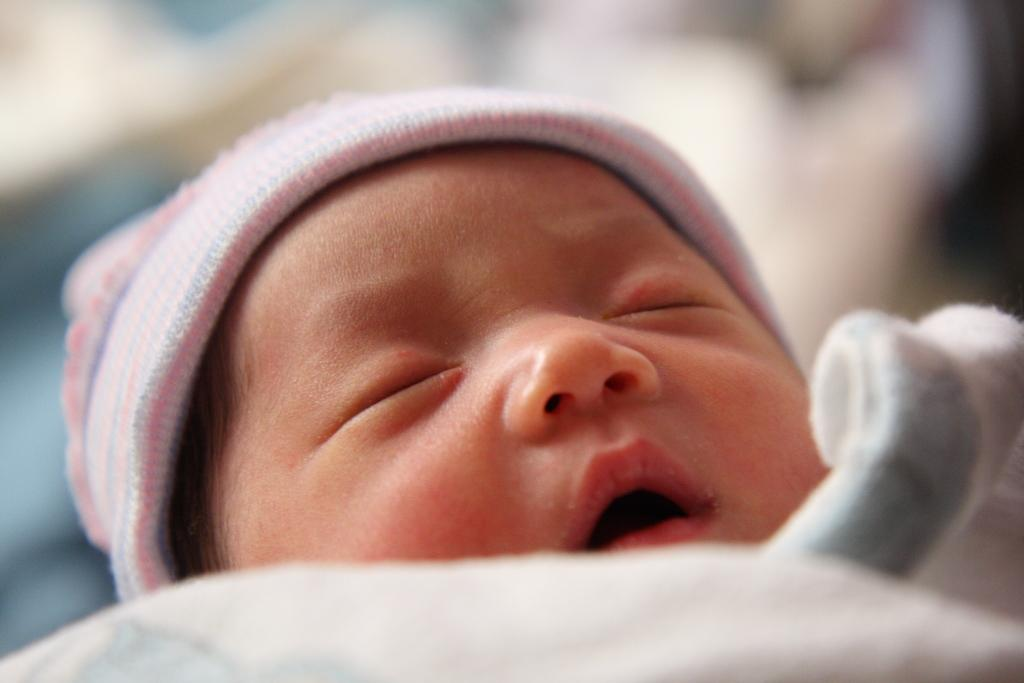What is the main subject of the image? There is a child in the image. What is the child doing in the image? The child is sleeping. Can you describe the background of the image? The background of the image is blurred. How many pies are on the bed next to the child in the image? There are no pies present in the image. What type of bedroom furniture can be seen in the image? The image does not show any bedroom furniture; it only shows a child sleeping with a blurred background. 